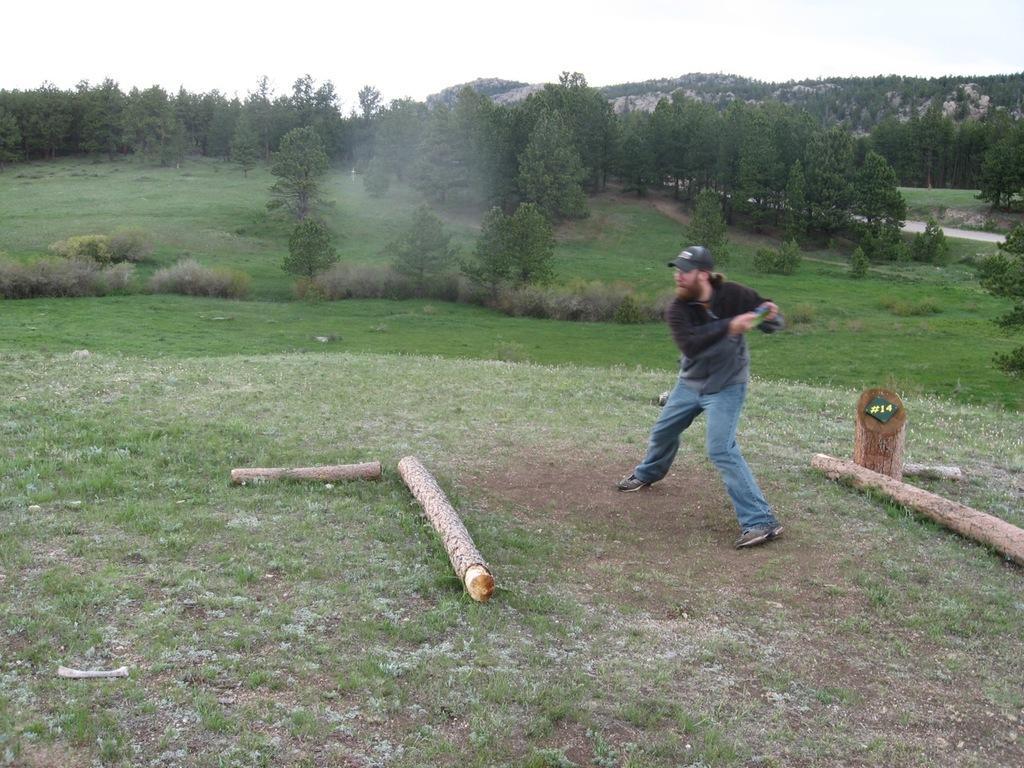Can you describe this image briefly? This picture is clicked outside. On the right there is a person seems to be standing on the ground and there are some objects placed on the ground. In the background we can see the sky, trees, plants and grass. 